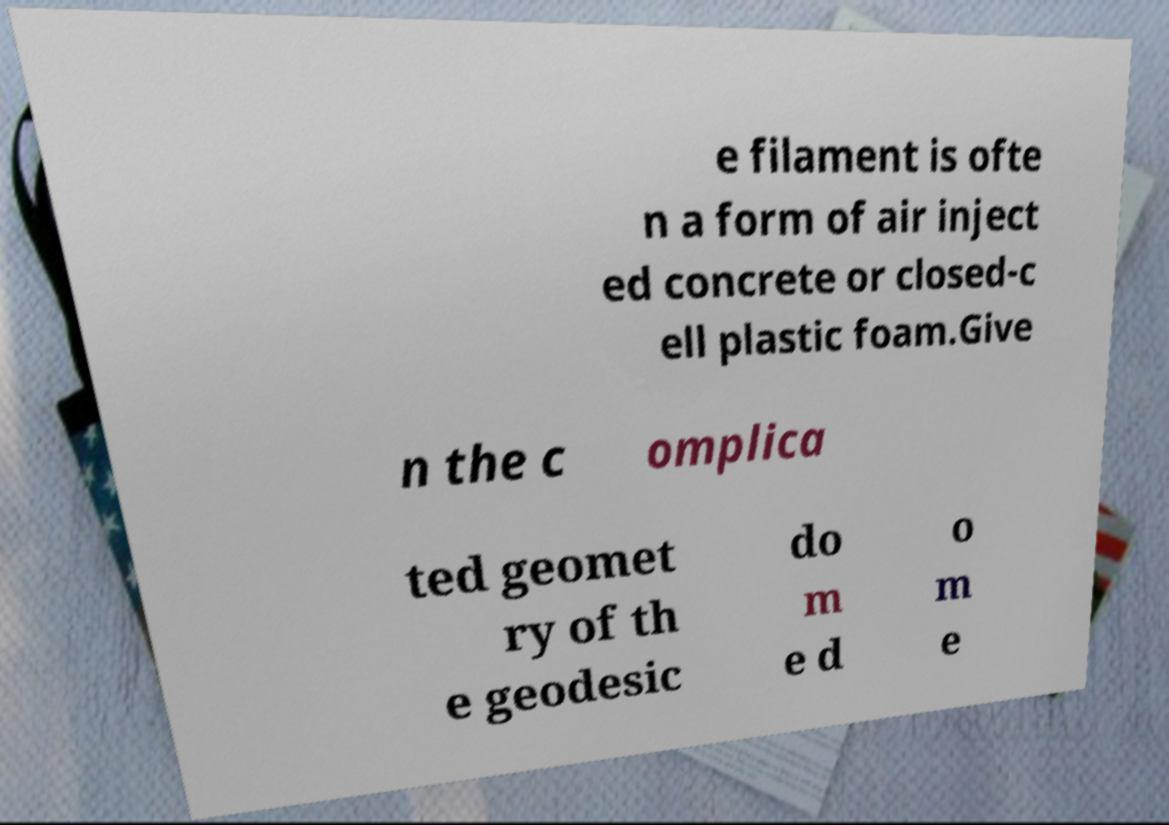Please identify and transcribe the text found in this image. e filament is ofte n a form of air inject ed concrete or closed-c ell plastic foam.Give n the c omplica ted geomet ry of th e geodesic do m e d o m e 